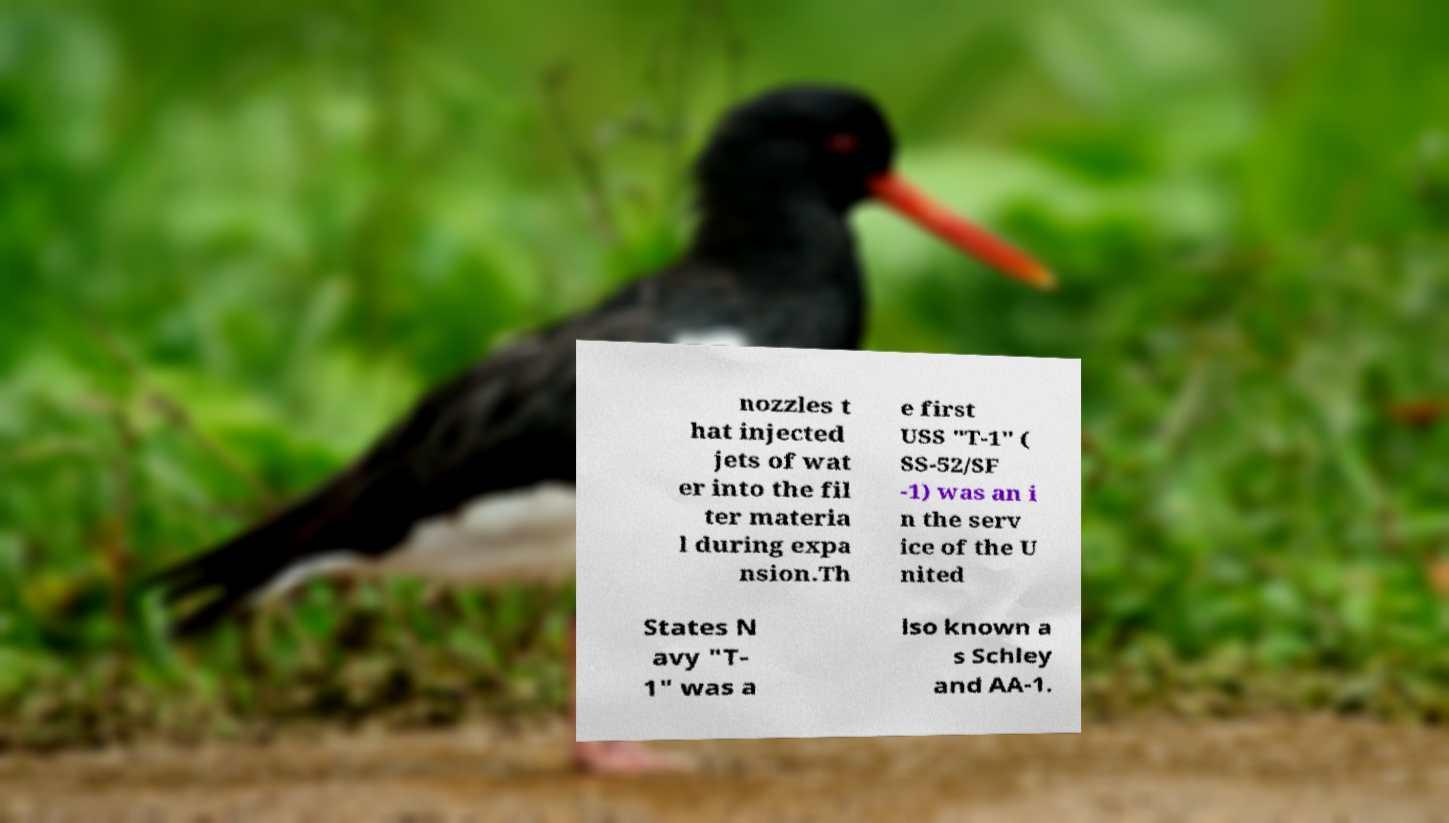Could you assist in decoding the text presented in this image and type it out clearly? nozzles t hat injected jets of wat er into the fil ter materia l during expa nsion.Th e first USS "T-1" ( SS-52/SF -1) was an i n the serv ice of the U nited States N avy "T- 1" was a lso known a s Schley and AA-1. 